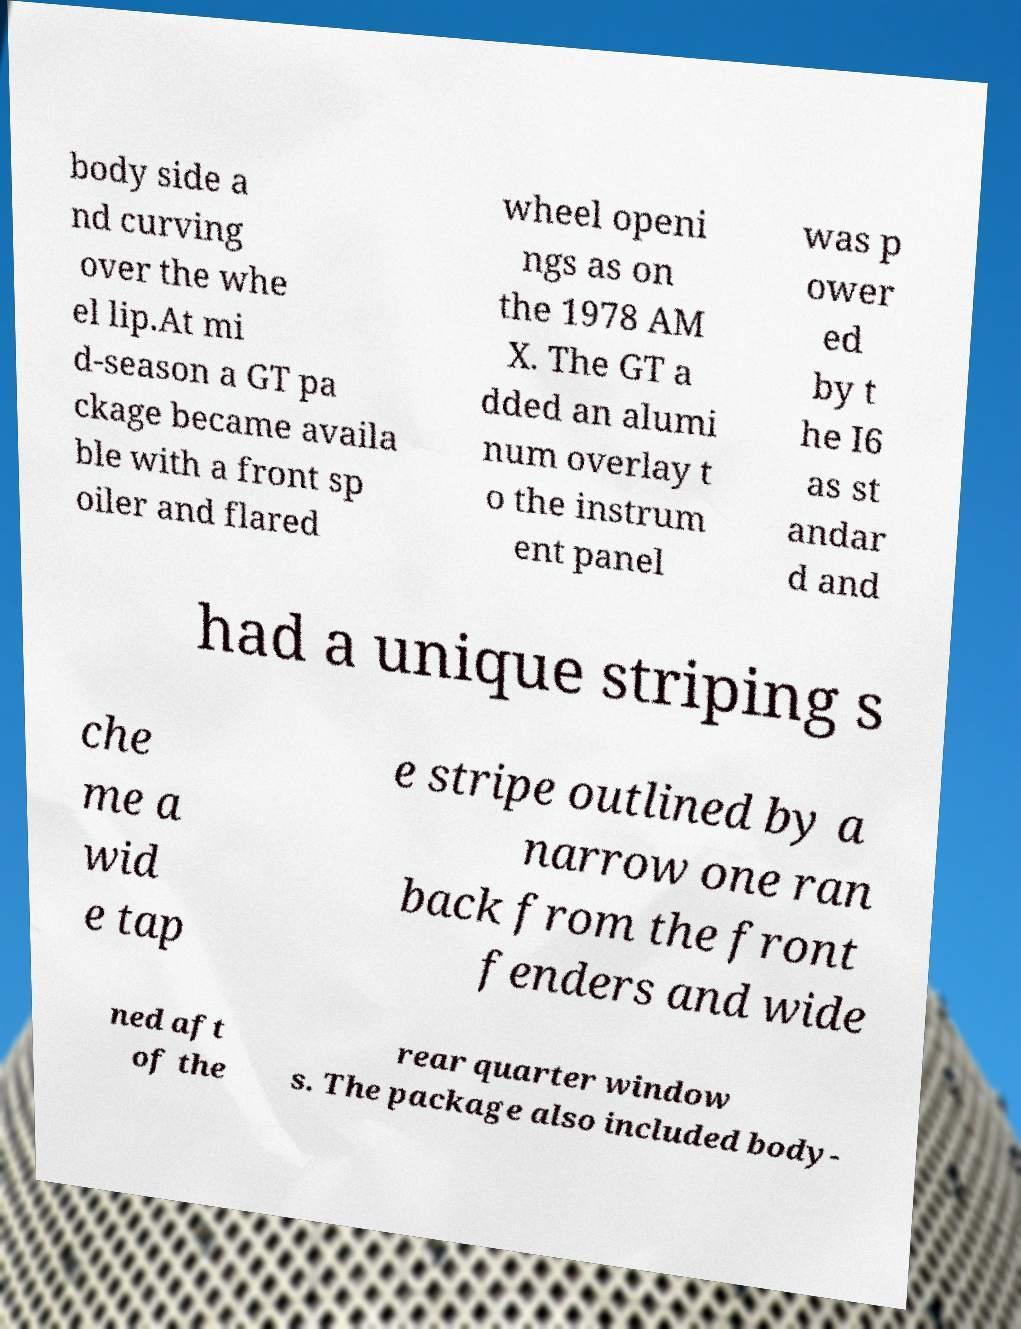Can you read and provide the text displayed in the image?This photo seems to have some interesting text. Can you extract and type it out for me? body side a nd curving over the whe el lip.At mi d-season a GT pa ckage became availa ble with a front sp oiler and flared wheel openi ngs as on the 1978 AM X. The GT a dded an alumi num overlay t o the instrum ent panel was p ower ed by t he I6 as st andar d and had a unique striping s che me a wid e tap e stripe outlined by a narrow one ran back from the front fenders and wide ned aft of the rear quarter window s. The package also included body- 